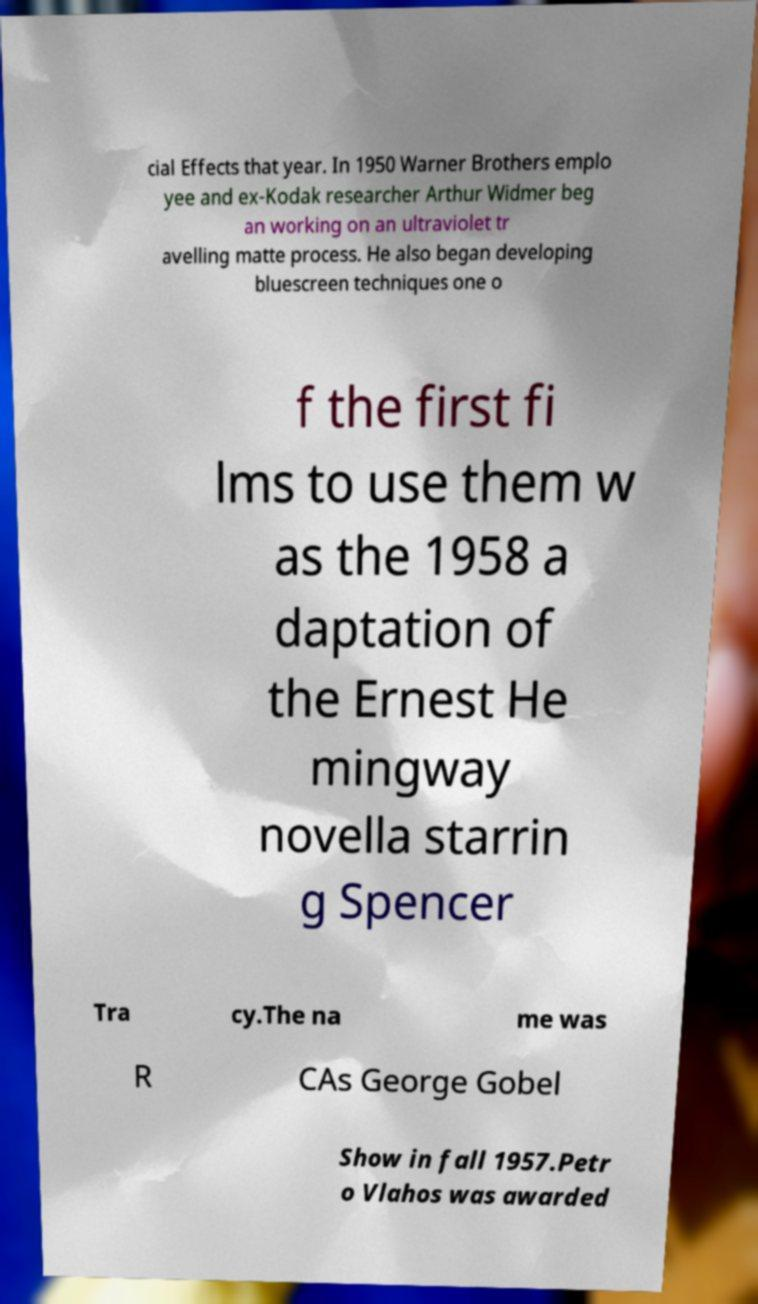There's text embedded in this image that I need extracted. Can you transcribe it verbatim? cial Effects that year. In 1950 Warner Brothers emplo yee and ex-Kodak researcher Arthur Widmer beg an working on an ultraviolet tr avelling matte process. He also began developing bluescreen techniques one o f the first fi lms to use them w as the 1958 a daptation of the Ernest He mingway novella starrin g Spencer Tra cy.The na me was R CAs George Gobel Show in fall 1957.Petr o Vlahos was awarded 